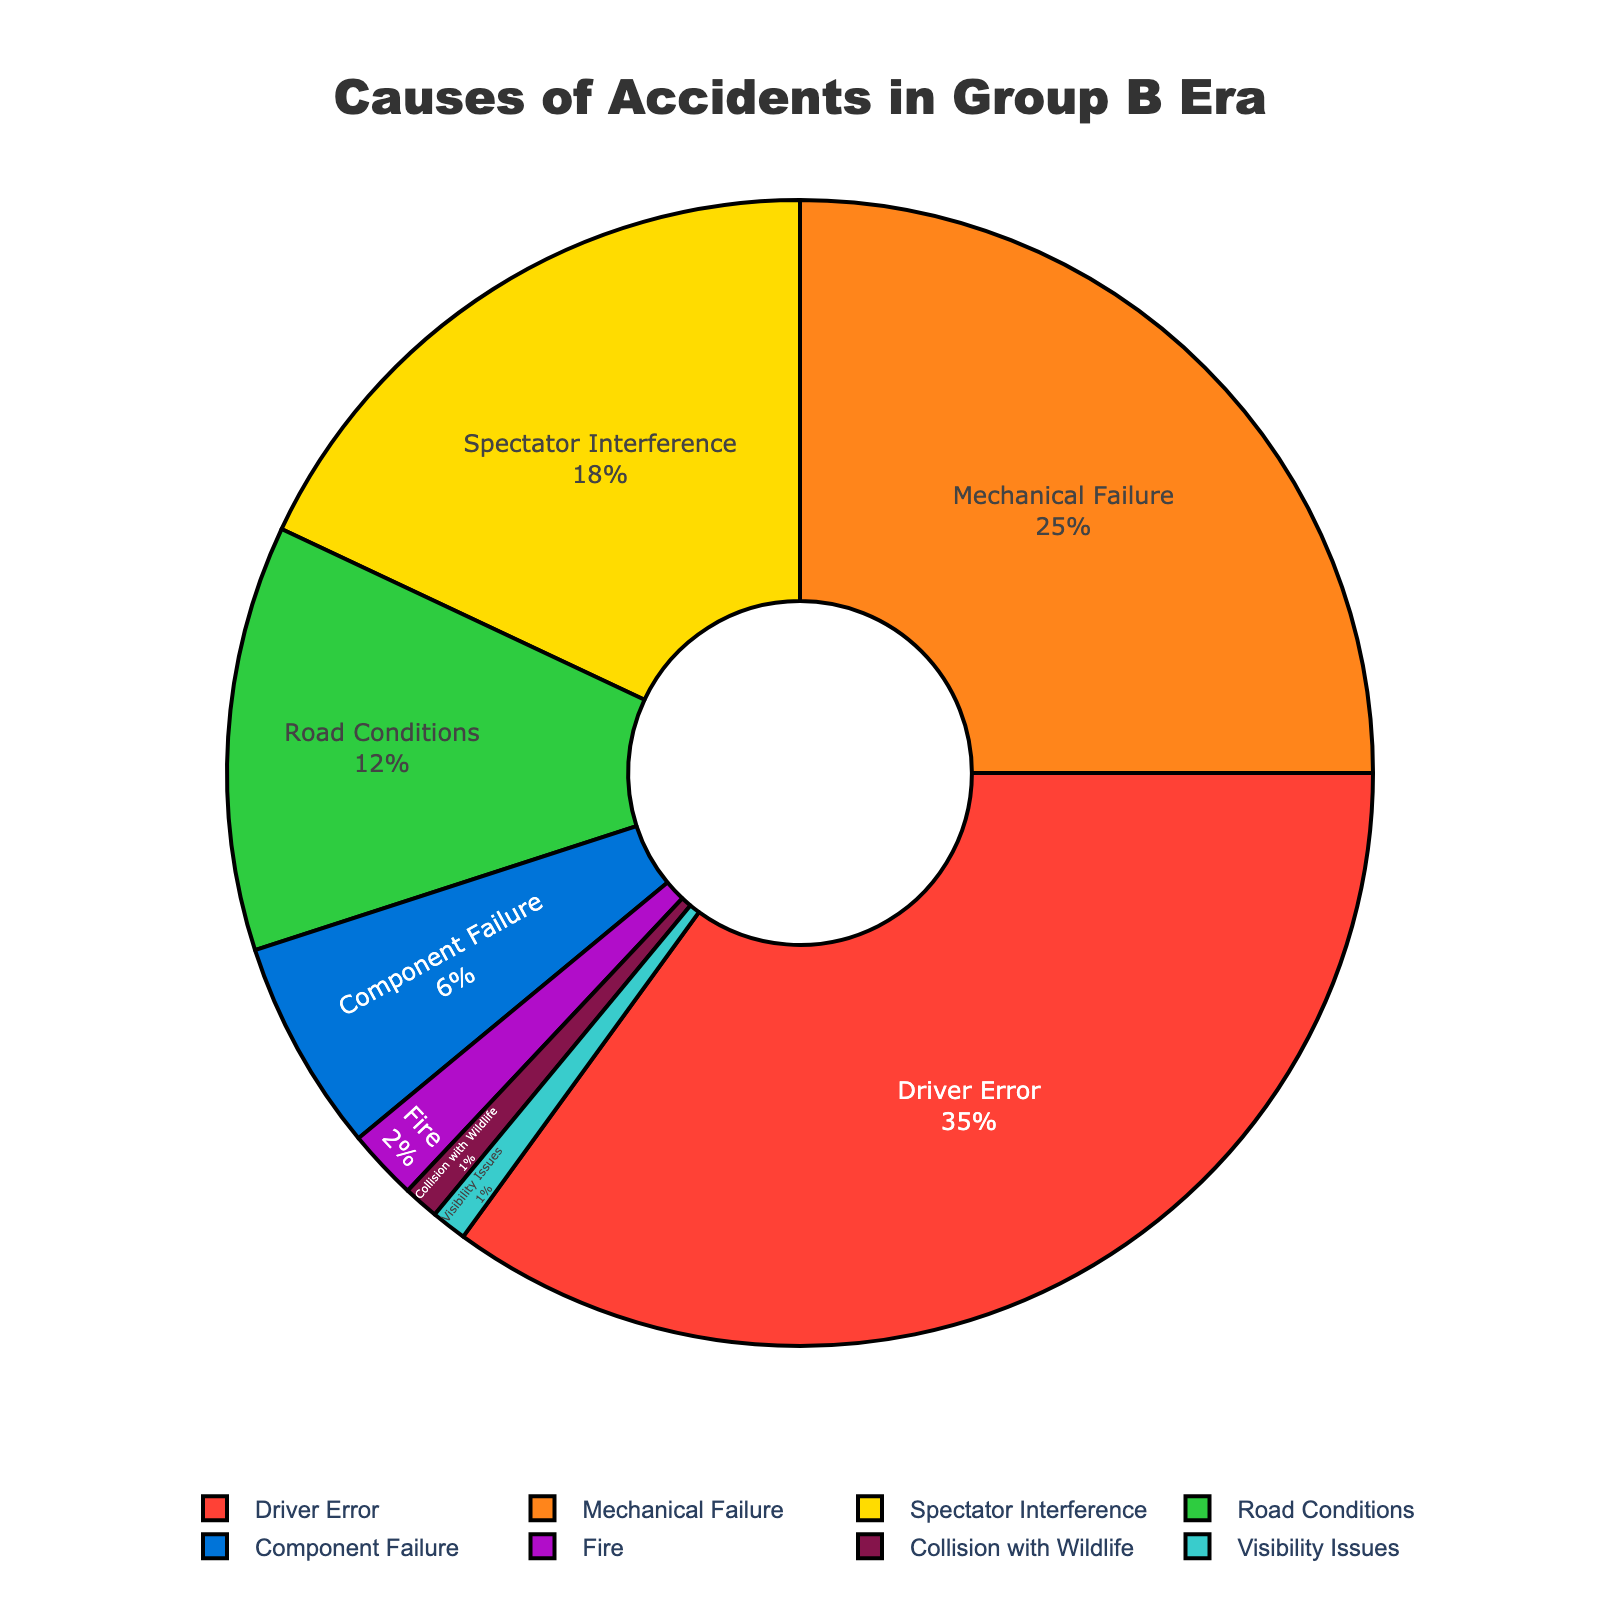What percentage of accidents are due to driver error? The pie chart shows the percentage, and we can directly read the value labeled "Driver Error" which is 35%.
Answer: 35% Which cause contributes more to accidents: mechanical failure or road conditions? Looking at the pie chart, the percentage for "Mechanical Failure" is 25% and for "Road Conditions" is 12%. Since 25% > 12%, mechanical failure contributes more.
Answer: Mechanical Failure What is the combined percentage of accidents caused by component failure and fire? The pie chart shows "Component Failure" at 6% and "Fire" at 2%. Adding these gives 6% + 2% = 8%.
Answer: 8% Which type of interference is more common, spectator interference or collision with wildlife? From the pie chart, "Spectator Interference" is 18% and "Collision with Wildlife" is 1%. Since 18% > 1%, spectator interference is more common.
Answer: Spectator Interference Which accident cause has the smallest percentage? The pie chart shows "Collision with Wildlife" and "Visibility Issues" both at 1%, so these are the smallest percentages.
Answer: Collision with Wildlife, Visibility Issues How many causes have a percentage higher than 10%? From the pie chart, the causes with percentages higher than 10% are "Driver Error" (35%), "Mechanical Failure" (25%), "Spectator Interference" (18%), and "Road Conditions" (12%). There are 4 such causes.
Answer: 4 What is the combined percentage of accidents caused by other factors not related to driver error or mechanical failure? Excluding "Driver Error" (35%) and "Mechanical Failure" (25%), the other factors sum up to 18% (Spectator Interference) + 12% (Road Conditions) + 6% (Component Failure) + 2% (Fire) + 1% (Collision with Wildlife) + 1% (Visibility Issues) = 40%.
Answer: 40% What percentage of accidents are due to factors involving the vehicle itself, like mechanical or component failure? The pie chart shows "Mechanical Failure" at 25% and "Component Failure" at 6%. Adding these we get 25% + 6% = 31%.
Answer: 31% Which cause of accidents is represented by the red portion of the pie? Looking at the colors used in the pie chart, the red portion corresponds to the largest segment, which is labeled "Driver Error" at 35%.
Answer: Driver Error 